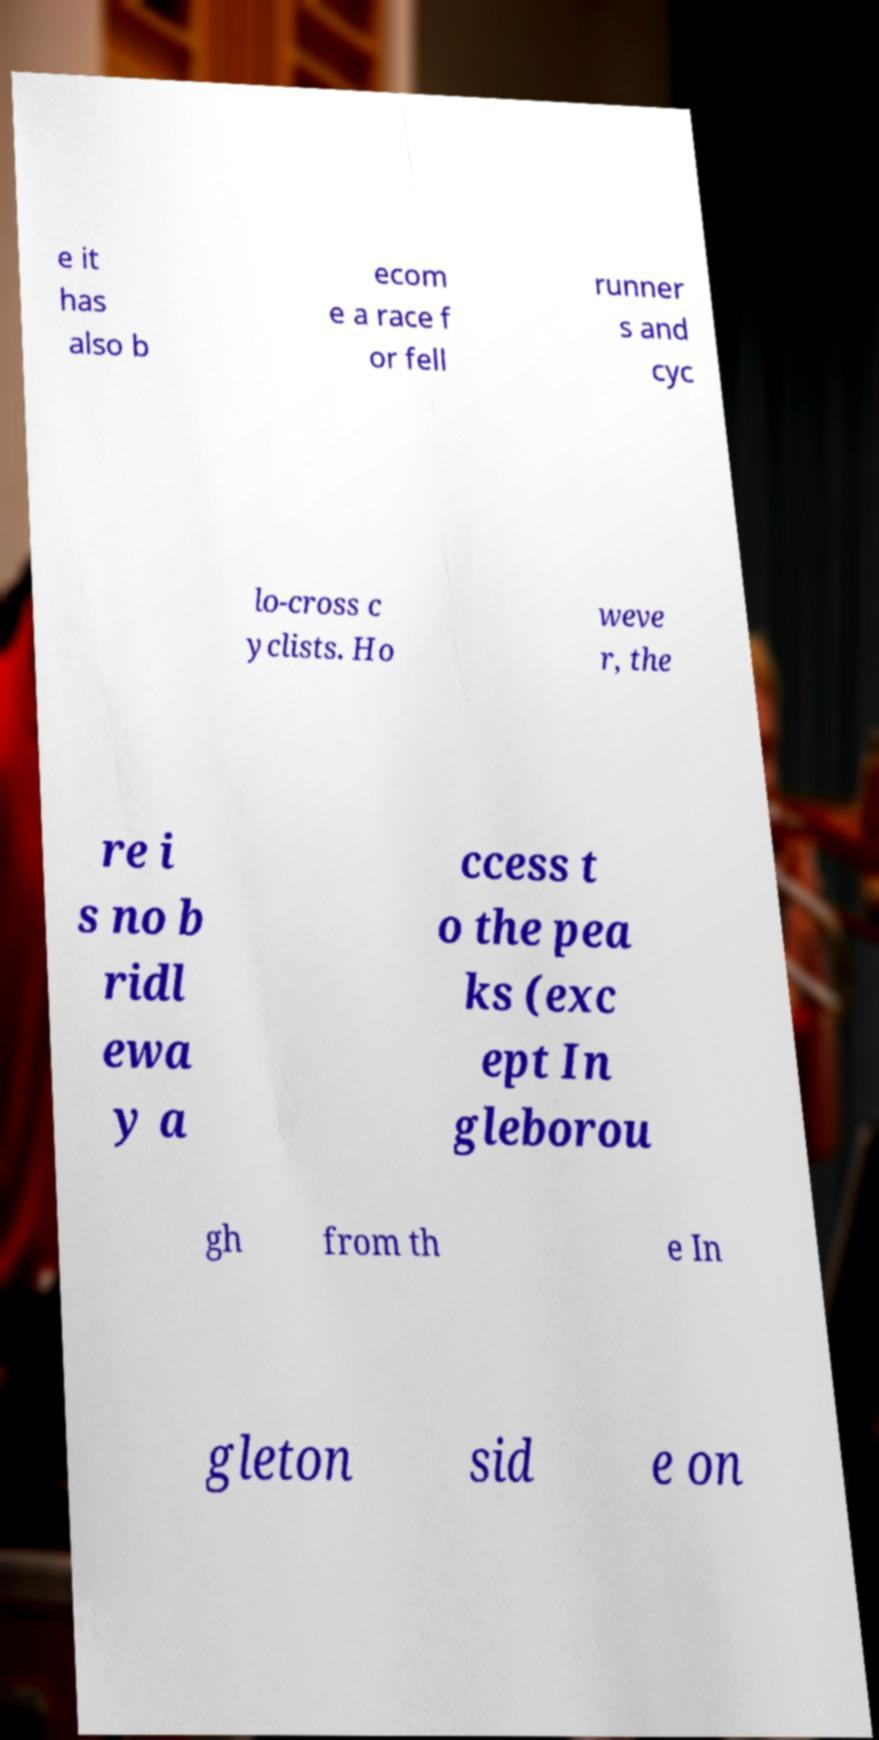Please identify and transcribe the text found in this image. e it has also b ecom e a race f or fell runner s and cyc lo-cross c yclists. Ho weve r, the re i s no b ridl ewa y a ccess t o the pea ks (exc ept In gleborou gh from th e In gleton sid e on 